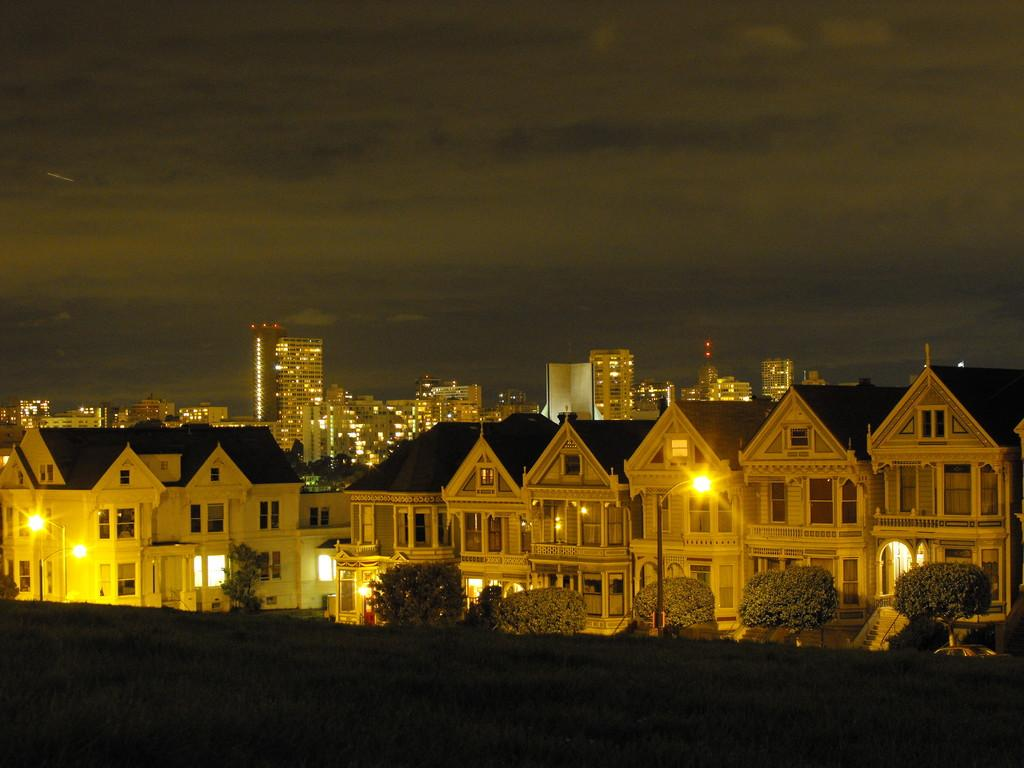What type of structures can be seen in the image? There are multiple buildings in the image. What can be seen illuminated in the image? There are lights visible in the image. What type of vegetation is present in the front of the image? There are trees in the front of the image. What type of vehicle is present in the front of the image? There is a car in the front of the image. What object is present in the front of the image, besides the car and trees? There is a pole in the front of the image. What is visible in the background of the image? There are clouds and the sky visible in the background of the image. What type of shirt is the alarm wearing in the image? There is no shirt or alarm present in the image. How can someone help the clouds in the image? The clouds in the image do not require help, as they are a natural atmospheric phenomenon. 